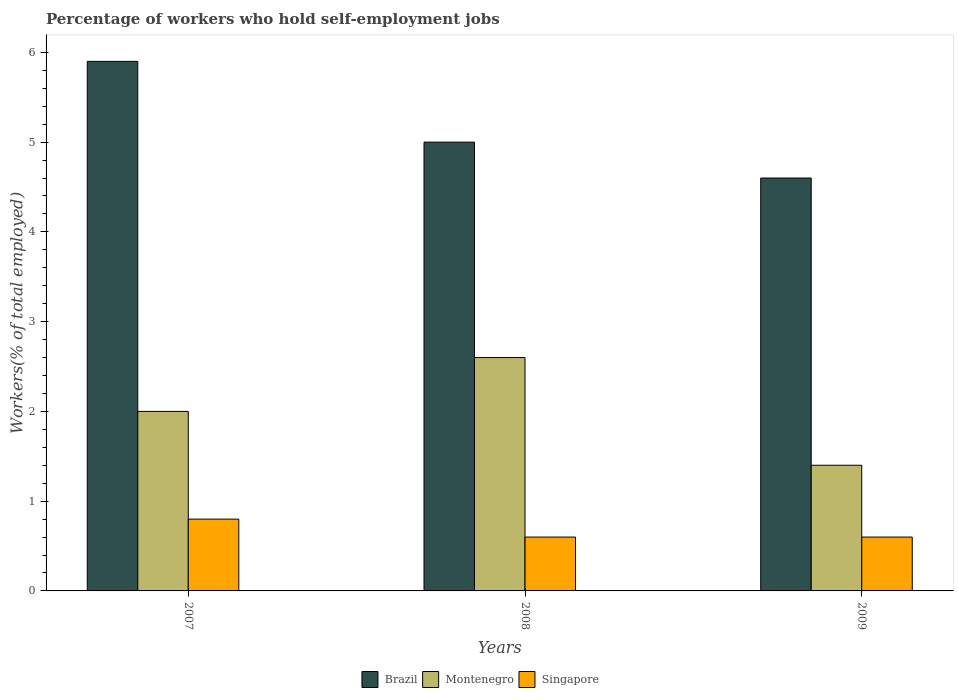How many different coloured bars are there?
Offer a very short reply. 3. How many groups of bars are there?
Give a very brief answer. 3. Are the number of bars per tick equal to the number of legend labels?
Your response must be concise. Yes. What is the label of the 3rd group of bars from the left?
Offer a very short reply. 2009. What is the percentage of self-employed workers in Montenegro in 2007?
Your answer should be very brief. 2. Across all years, what is the maximum percentage of self-employed workers in Singapore?
Provide a short and direct response. 0.8. Across all years, what is the minimum percentage of self-employed workers in Montenegro?
Offer a terse response. 1.4. In which year was the percentage of self-employed workers in Montenegro maximum?
Offer a very short reply. 2008. In which year was the percentage of self-employed workers in Brazil minimum?
Give a very brief answer. 2009. What is the total percentage of self-employed workers in Brazil in the graph?
Offer a terse response. 15.5. What is the difference between the percentage of self-employed workers in Montenegro in 2007 and that in 2008?
Ensure brevity in your answer.  -0.6. What is the difference between the percentage of self-employed workers in Brazil in 2008 and the percentage of self-employed workers in Montenegro in 2009?
Ensure brevity in your answer.  3.6. What is the average percentage of self-employed workers in Brazil per year?
Ensure brevity in your answer.  5.17. In the year 2009, what is the difference between the percentage of self-employed workers in Singapore and percentage of self-employed workers in Montenegro?
Offer a terse response. -0.8. What is the ratio of the percentage of self-employed workers in Singapore in 2007 to that in 2008?
Make the answer very short. 1.33. What is the difference between the highest and the second highest percentage of self-employed workers in Singapore?
Your answer should be very brief. 0.2. What is the difference between the highest and the lowest percentage of self-employed workers in Montenegro?
Make the answer very short. 1.2. In how many years, is the percentage of self-employed workers in Montenegro greater than the average percentage of self-employed workers in Montenegro taken over all years?
Your answer should be compact. 2. Is the sum of the percentage of self-employed workers in Brazil in 2007 and 2009 greater than the maximum percentage of self-employed workers in Singapore across all years?
Give a very brief answer. Yes. What does the 2nd bar from the left in 2007 represents?
Your response must be concise. Montenegro. What does the 1st bar from the right in 2007 represents?
Provide a succinct answer. Singapore. Is it the case that in every year, the sum of the percentage of self-employed workers in Brazil and percentage of self-employed workers in Montenegro is greater than the percentage of self-employed workers in Singapore?
Offer a terse response. Yes. How many years are there in the graph?
Your answer should be very brief. 3. What is the difference between two consecutive major ticks on the Y-axis?
Ensure brevity in your answer.  1. Where does the legend appear in the graph?
Offer a very short reply. Bottom center. How are the legend labels stacked?
Provide a succinct answer. Horizontal. What is the title of the graph?
Your response must be concise. Percentage of workers who hold self-employment jobs. Does "United Arab Emirates" appear as one of the legend labels in the graph?
Provide a short and direct response. No. What is the label or title of the Y-axis?
Your answer should be very brief. Workers(% of total employed). What is the Workers(% of total employed) in Brazil in 2007?
Keep it short and to the point. 5.9. What is the Workers(% of total employed) of Singapore in 2007?
Your answer should be compact. 0.8. What is the Workers(% of total employed) of Montenegro in 2008?
Provide a short and direct response. 2.6. What is the Workers(% of total employed) in Singapore in 2008?
Make the answer very short. 0.6. What is the Workers(% of total employed) in Brazil in 2009?
Your response must be concise. 4.6. What is the Workers(% of total employed) of Montenegro in 2009?
Offer a terse response. 1.4. What is the Workers(% of total employed) of Singapore in 2009?
Your response must be concise. 0.6. Across all years, what is the maximum Workers(% of total employed) in Brazil?
Your response must be concise. 5.9. Across all years, what is the maximum Workers(% of total employed) of Montenegro?
Keep it short and to the point. 2.6. Across all years, what is the maximum Workers(% of total employed) in Singapore?
Your answer should be very brief. 0.8. Across all years, what is the minimum Workers(% of total employed) of Brazil?
Offer a terse response. 4.6. Across all years, what is the minimum Workers(% of total employed) in Montenegro?
Ensure brevity in your answer.  1.4. Across all years, what is the minimum Workers(% of total employed) in Singapore?
Give a very brief answer. 0.6. What is the total Workers(% of total employed) of Brazil in the graph?
Your answer should be compact. 15.5. What is the difference between the Workers(% of total employed) in Brazil in 2007 and that in 2008?
Give a very brief answer. 0.9. What is the difference between the Workers(% of total employed) of Singapore in 2007 and that in 2008?
Provide a short and direct response. 0.2. What is the difference between the Workers(% of total employed) of Brazil in 2007 and that in 2009?
Your answer should be very brief. 1.3. What is the difference between the Workers(% of total employed) of Brazil in 2008 and that in 2009?
Provide a succinct answer. 0.4. What is the difference between the Workers(% of total employed) in Singapore in 2008 and that in 2009?
Make the answer very short. 0. What is the difference between the Workers(% of total employed) of Brazil in 2007 and the Workers(% of total employed) of Montenegro in 2008?
Make the answer very short. 3.3. What is the difference between the Workers(% of total employed) of Brazil in 2007 and the Workers(% of total employed) of Singapore in 2009?
Give a very brief answer. 5.3. What is the difference between the Workers(% of total employed) in Montenegro in 2007 and the Workers(% of total employed) in Singapore in 2009?
Provide a succinct answer. 1.4. What is the average Workers(% of total employed) of Brazil per year?
Your answer should be compact. 5.17. What is the average Workers(% of total employed) in Montenegro per year?
Your answer should be compact. 2. What is the average Workers(% of total employed) of Singapore per year?
Offer a terse response. 0.67. In the year 2007, what is the difference between the Workers(% of total employed) of Brazil and Workers(% of total employed) of Montenegro?
Keep it short and to the point. 3.9. In the year 2008, what is the difference between the Workers(% of total employed) in Brazil and Workers(% of total employed) in Montenegro?
Provide a short and direct response. 2.4. In the year 2008, what is the difference between the Workers(% of total employed) in Brazil and Workers(% of total employed) in Singapore?
Your response must be concise. 4.4. In the year 2008, what is the difference between the Workers(% of total employed) of Montenegro and Workers(% of total employed) of Singapore?
Keep it short and to the point. 2. In the year 2009, what is the difference between the Workers(% of total employed) of Brazil and Workers(% of total employed) of Singapore?
Keep it short and to the point. 4. What is the ratio of the Workers(% of total employed) of Brazil in 2007 to that in 2008?
Offer a very short reply. 1.18. What is the ratio of the Workers(% of total employed) in Montenegro in 2007 to that in 2008?
Ensure brevity in your answer.  0.77. What is the ratio of the Workers(% of total employed) in Brazil in 2007 to that in 2009?
Ensure brevity in your answer.  1.28. What is the ratio of the Workers(% of total employed) in Montenegro in 2007 to that in 2009?
Offer a very short reply. 1.43. What is the ratio of the Workers(% of total employed) in Singapore in 2007 to that in 2009?
Provide a succinct answer. 1.33. What is the ratio of the Workers(% of total employed) in Brazil in 2008 to that in 2009?
Provide a succinct answer. 1.09. What is the ratio of the Workers(% of total employed) in Montenegro in 2008 to that in 2009?
Your answer should be compact. 1.86. What is the ratio of the Workers(% of total employed) of Singapore in 2008 to that in 2009?
Provide a succinct answer. 1. What is the difference between the highest and the second highest Workers(% of total employed) in Brazil?
Offer a terse response. 0.9. What is the difference between the highest and the second highest Workers(% of total employed) of Montenegro?
Provide a short and direct response. 0.6. What is the difference between the highest and the lowest Workers(% of total employed) of Montenegro?
Your response must be concise. 1.2. What is the difference between the highest and the lowest Workers(% of total employed) in Singapore?
Your response must be concise. 0.2. 